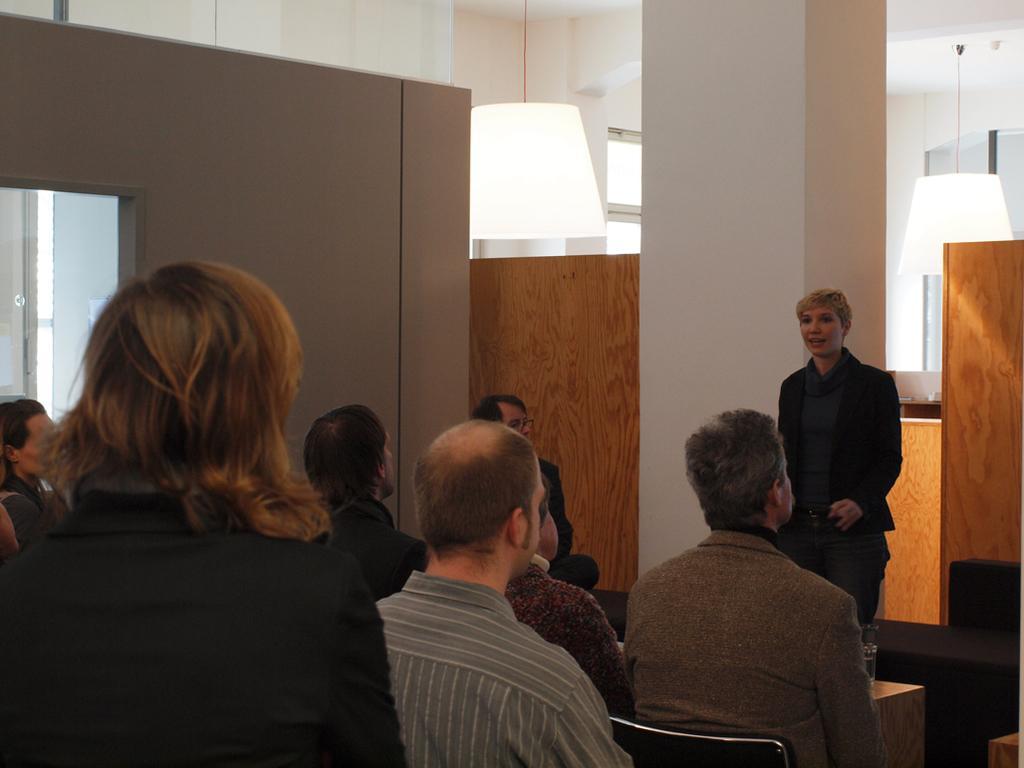In one or two sentences, can you explain what this image depicts? In this picture there are people setting and there is a person over here standing and talking 